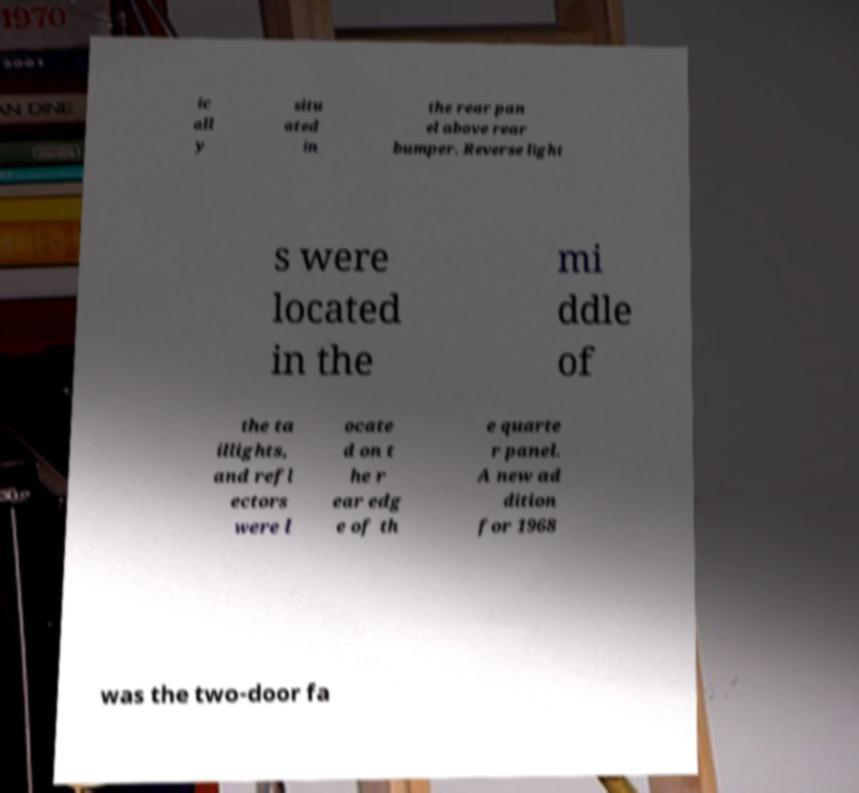Can you read and provide the text displayed in the image?This photo seems to have some interesting text. Can you extract and type it out for me? ic all y situ ated in the rear pan el above rear bumper. Reverse light s were located in the mi ddle of the ta illights, and refl ectors were l ocate d on t he r ear edg e of th e quarte r panel. A new ad dition for 1968 was the two-door fa 